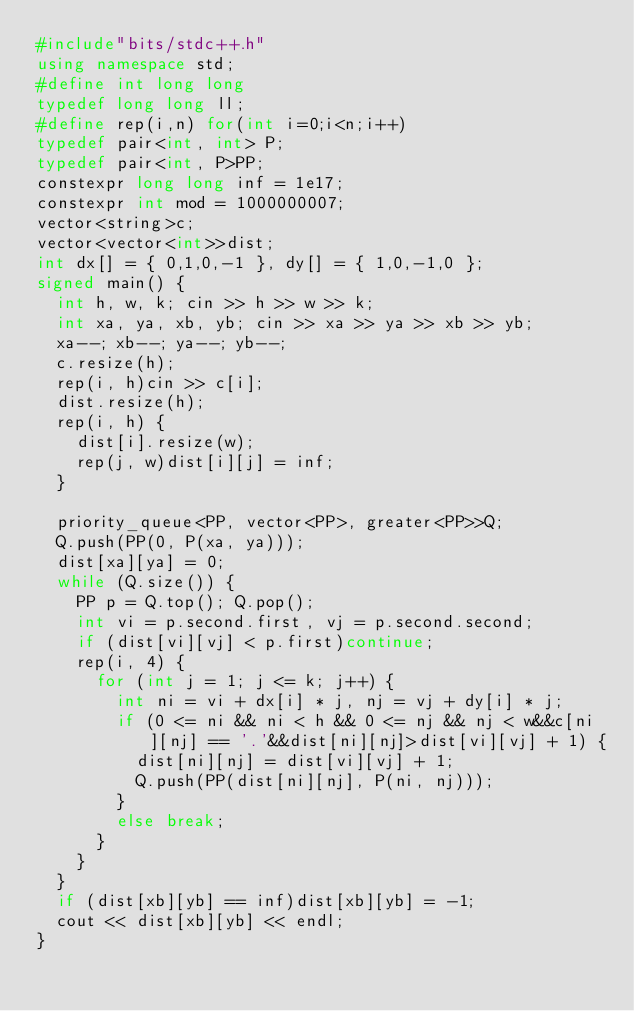<code> <loc_0><loc_0><loc_500><loc_500><_C++_>#include"bits/stdc++.h"
using namespace std;
#define int long long
typedef long long ll;
#define rep(i,n) for(int i=0;i<n;i++)
typedef pair<int, int> P;
typedef pair<int, P>PP;
constexpr long long inf = 1e17;
constexpr int mod = 1000000007;
vector<string>c;
vector<vector<int>>dist;
int dx[] = { 0,1,0,-1 }, dy[] = { 1,0,-1,0 };
signed main() {
	int h, w, k; cin >> h >> w >> k;
	int xa, ya, xb, yb; cin >> xa >> ya >> xb >> yb;
	xa--; xb--; ya--; yb--;
	c.resize(h);
	rep(i, h)cin >> c[i];
	dist.resize(h);
	rep(i, h) {
		dist[i].resize(w);
		rep(j, w)dist[i][j] = inf;
	}

	priority_queue<PP, vector<PP>, greater<PP>>Q;
	Q.push(PP(0, P(xa, ya)));
	dist[xa][ya] = 0;
	while (Q.size()) {
		PP p = Q.top(); Q.pop();
		int vi = p.second.first, vj = p.second.second;
		if (dist[vi][vj] < p.first)continue;
		rep(i, 4) {
			for (int j = 1; j <= k; j++) {
				int ni = vi + dx[i] * j, nj = vj + dy[i] * j;
				if (0 <= ni && ni < h && 0 <= nj && nj < w&&c[ni][nj] == '.'&&dist[ni][nj]>dist[vi][vj] + 1) {
					dist[ni][nj] = dist[vi][vj] + 1;
					Q.push(PP(dist[ni][nj], P(ni, nj)));
				}
				else break;
			}
		}
	}
	if (dist[xb][yb] == inf)dist[xb][yb] = -1;
	cout << dist[xb][yb] << endl;
}</code> 